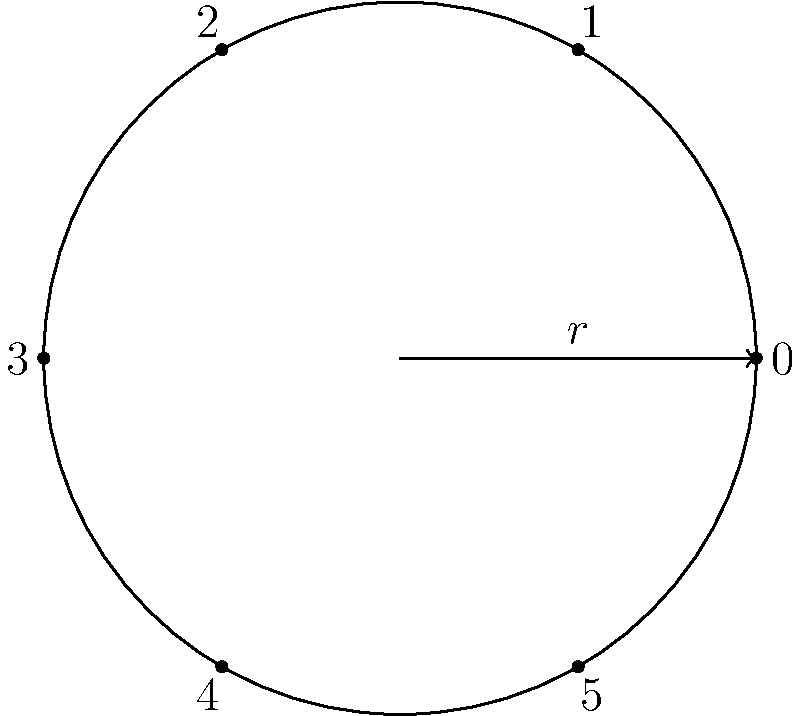I en cirkulär representation av den cykliska gruppen $C_6$, hur många rotationer behövs för att flytta element $2$ till positionen för element $5$? För att lösa detta problem, följ dessa steg:

1. Identifiera gruppens ordning:
   - Gruppen $C_6$ har 6 element, numrerade från 0 till 5.

2. Förstå rotationen:
   - En rotation flyttar varje element ett steg medurs.

3. Beräkna avståndet mellan element 2 och 5:
   - Från 2 till 5 är det 3 steg medurs.

4. Alternativt, använd modulo-aritmetik:
   - $(5 - 2) \bmod 6 = 3$

5. Kontrollera:
   - Efter 3 rotationer har element 2 flyttats till position 5.

Därför behövs 3 rotationer för att flytta element 2 till positionen för element 5.
Answer: 3 